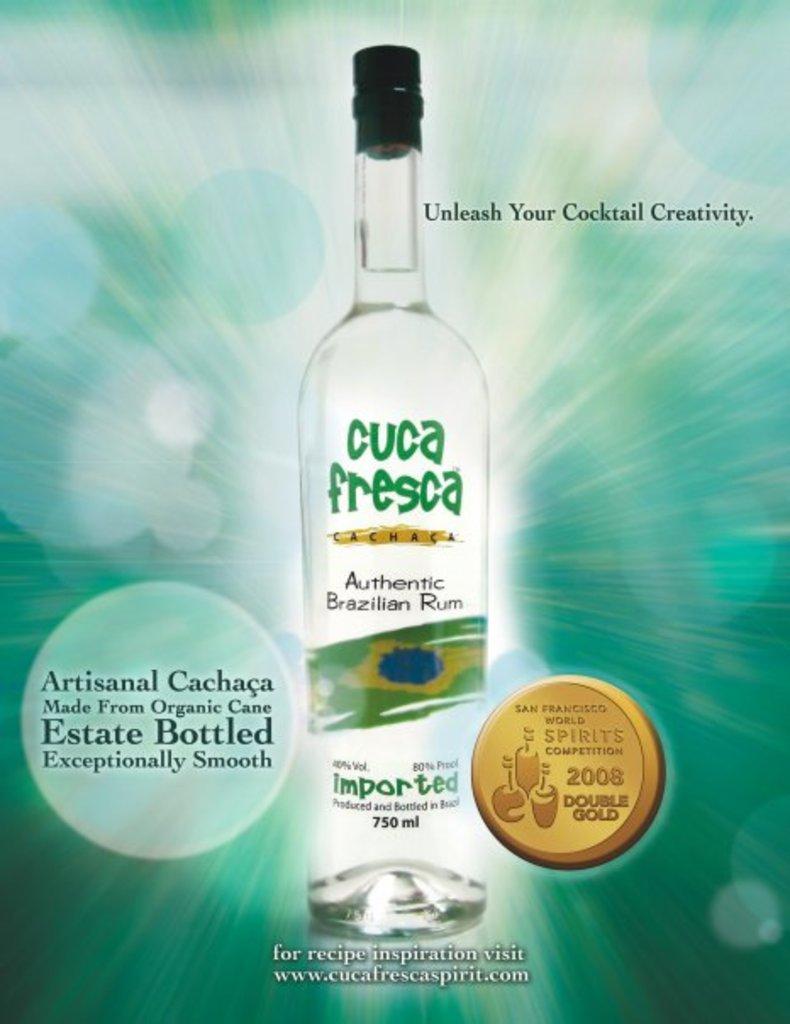What alcohol is this?
Offer a terse response. Rum. 